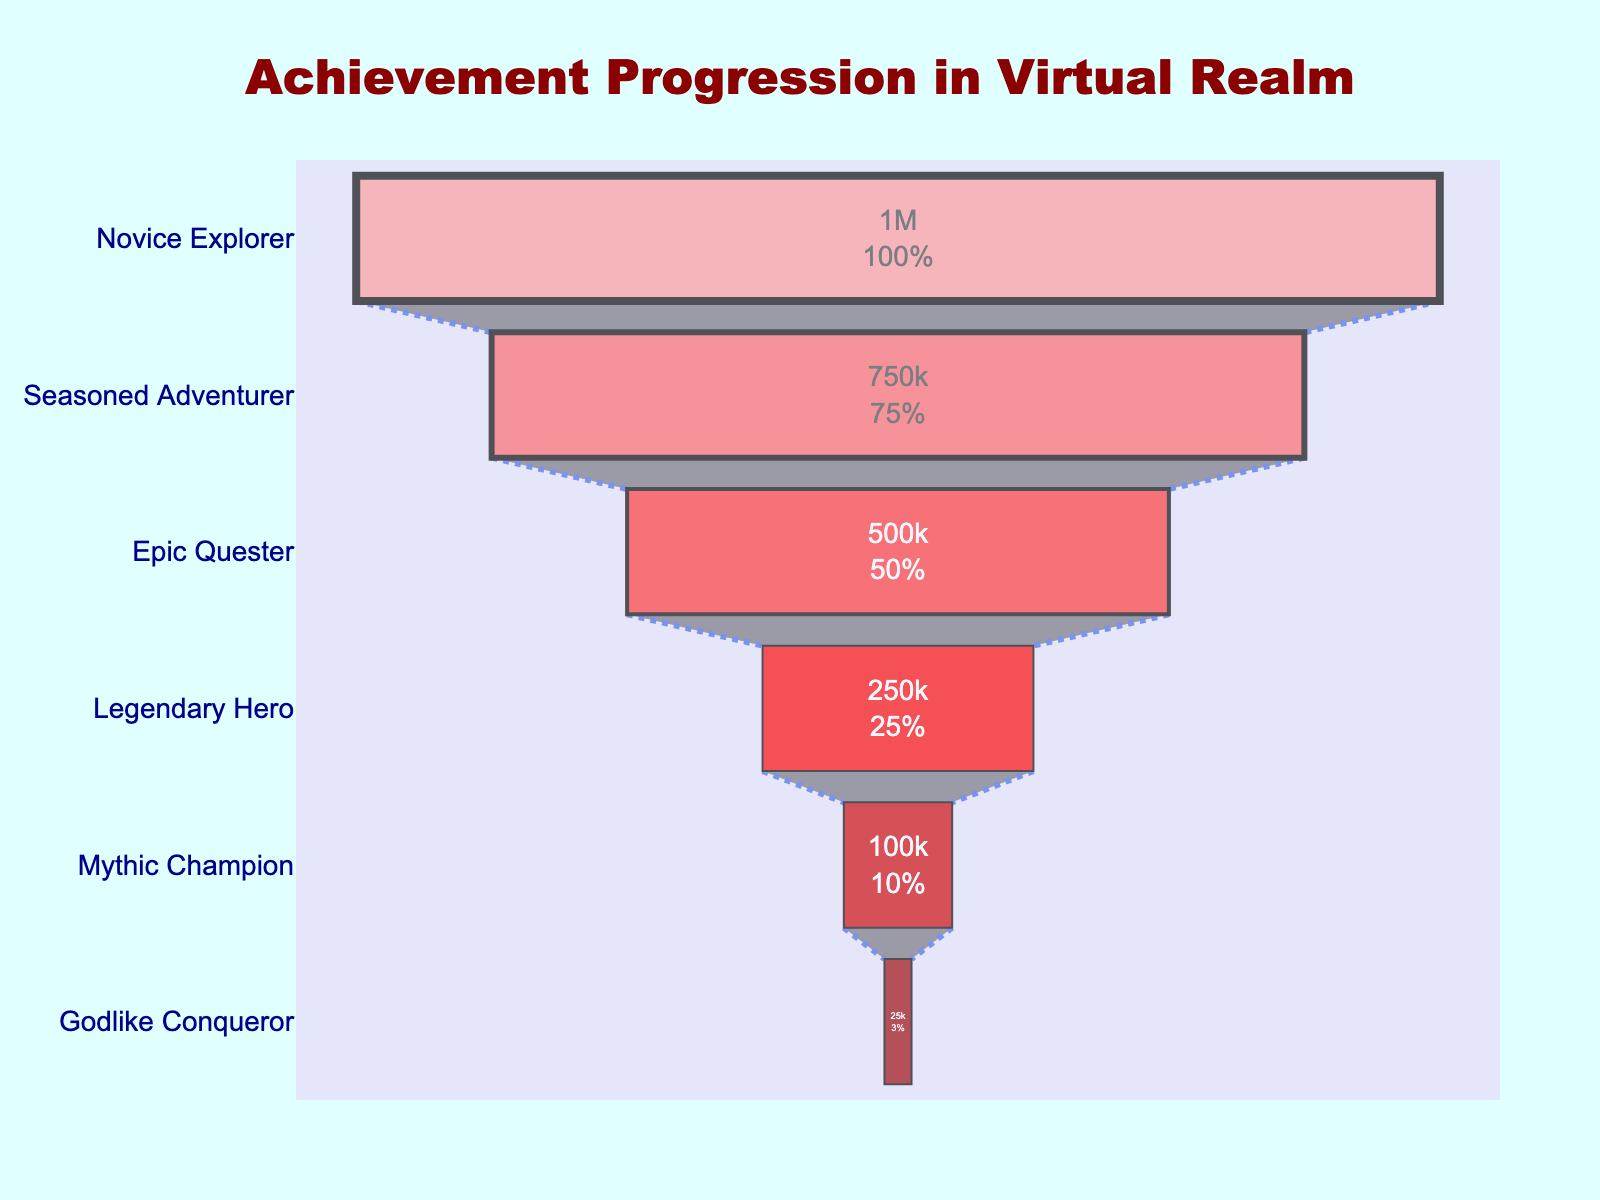What's the title of the plot? The title is displayed prominently at the top of the plot in bold, dark red text.
Answer: Achievement Progression in Virtual Realm What is the total number of players represented in the first stage (Novice Explorer)? The value is shown inside the first stage of the funnel.
Answer: 1,000,000 How many players achieved the Mythic Champion status? The number is inside the funnel section labeled "Mythic Champion".
Answer: 100,000 What percentage of the initial players completed the Godlike Conqueror stage? The percentage is shown inside the Godlike Conqueror section of the funnel.
Answer: 2.5% How many players are lost between the Epic Quester and Legendary Hero stages? Subtract the number of players in the Legendary Hero stage from those in the Epic Quester stage.
Answer: 250,000 Which stage has the widest section in the funnel chart? The widest section corresponds to the stage with the highest number of players, shown at the top of the chart.
Answer: Novice Explorer What’s the decrease in player count from Seasoned Adventurer to Epic Quester? Subtract the number of players in the Epic Quester stage from those in the Seasoned Adventurer stage.
Answer: 250,000 How does the color change as you progress through the achievements? Observing the funnel chart, the color becomes progressively darker from top to bottom.
Answer: Darker What is the order of achievements mentioned on the y-axis from top to bottom? Read the list of achievements from the topmost stage to the bottommost stage on the y-axis.
Answer: Novice Explorer, Seasoned Adventurer, Epic Quester, Legendary Hero, Mythic Champion, Godlike Conqueror What percentage of players that achieve the Epic Quester status go on to become a Legendary Hero? Divide the number of Legendary Heroes by the number of Epic Questers, then multiply by 100 to get the percentage: (250,000 / 500,000) * 100.
Answer: 50% 